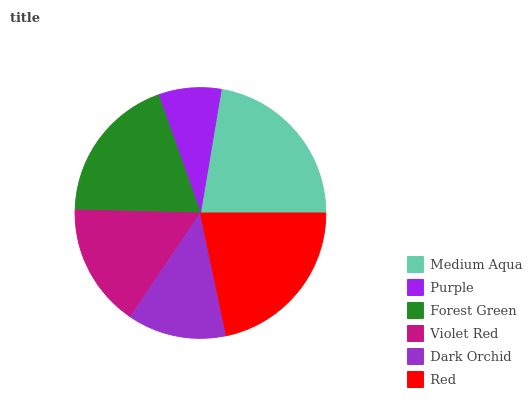Is Purple the minimum?
Answer yes or no. Yes. Is Medium Aqua the maximum?
Answer yes or no. Yes. Is Forest Green the minimum?
Answer yes or no. No. Is Forest Green the maximum?
Answer yes or no. No. Is Forest Green greater than Purple?
Answer yes or no. Yes. Is Purple less than Forest Green?
Answer yes or no. Yes. Is Purple greater than Forest Green?
Answer yes or no. No. Is Forest Green less than Purple?
Answer yes or no. No. Is Forest Green the high median?
Answer yes or no. Yes. Is Violet Red the low median?
Answer yes or no. Yes. Is Medium Aqua the high median?
Answer yes or no. No. Is Red the low median?
Answer yes or no. No. 